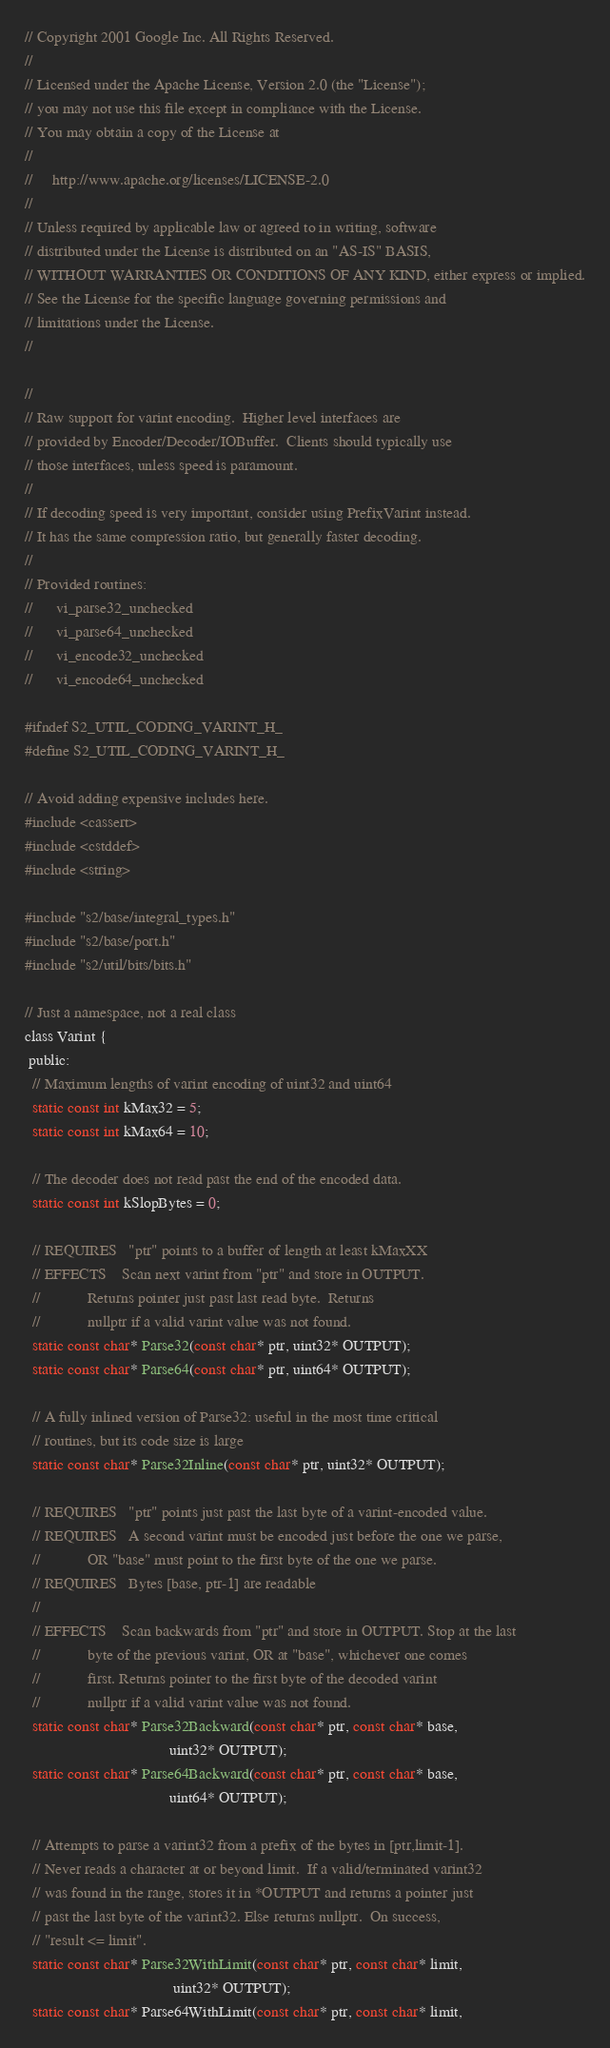<code> <loc_0><loc_0><loc_500><loc_500><_C_>// Copyright 2001 Google Inc. All Rights Reserved.
//
// Licensed under the Apache License, Version 2.0 (the "License");
// you may not use this file except in compliance with the License.
// You may obtain a copy of the License at
//
//     http://www.apache.org/licenses/LICENSE-2.0
//
// Unless required by applicable law or agreed to in writing, software
// distributed under the License is distributed on an "AS-IS" BASIS,
// WITHOUT WARRANTIES OR CONDITIONS OF ANY KIND, either express or implied.
// See the License for the specific language governing permissions and
// limitations under the License.
//

//
// Raw support for varint encoding.  Higher level interfaces are
// provided by Encoder/Decoder/IOBuffer.  Clients should typically use
// those interfaces, unless speed is paramount.
//
// If decoding speed is very important, consider using PrefixVarint instead.
// It has the same compression ratio, but generally faster decoding.
//
// Provided routines:
//      vi_parse32_unchecked
//      vi_parse64_unchecked
//      vi_encode32_unchecked
//      vi_encode64_unchecked

#ifndef S2_UTIL_CODING_VARINT_H_
#define S2_UTIL_CODING_VARINT_H_

// Avoid adding expensive includes here.
#include <cassert>
#include <cstddef>
#include <string>

#include "s2/base/integral_types.h"
#include "s2/base/port.h"
#include "s2/util/bits/bits.h"

// Just a namespace, not a real class
class Varint {
 public:
  // Maximum lengths of varint encoding of uint32 and uint64
  static const int kMax32 = 5;
  static const int kMax64 = 10;

  // The decoder does not read past the end of the encoded data.
  static const int kSlopBytes = 0;

  // REQUIRES   "ptr" points to a buffer of length at least kMaxXX
  // EFFECTS    Scan next varint from "ptr" and store in OUTPUT.
  //            Returns pointer just past last read byte.  Returns
  //            nullptr if a valid varint value was not found.
  static const char* Parse32(const char* ptr, uint32* OUTPUT);
  static const char* Parse64(const char* ptr, uint64* OUTPUT);

  // A fully inlined version of Parse32: useful in the most time critical
  // routines, but its code size is large
  static const char* Parse32Inline(const char* ptr, uint32* OUTPUT);

  // REQUIRES   "ptr" points just past the last byte of a varint-encoded value.
  // REQUIRES   A second varint must be encoded just before the one we parse,
  //            OR "base" must point to the first byte of the one we parse.
  // REQUIRES   Bytes [base, ptr-1] are readable
  //
  // EFFECTS    Scan backwards from "ptr" and store in OUTPUT. Stop at the last
  //            byte of the previous varint, OR at "base", whichever one comes
  //            first. Returns pointer to the first byte of the decoded varint
  //            nullptr if a valid varint value was not found.
  static const char* Parse32Backward(const char* ptr, const char* base,
                                     uint32* OUTPUT);
  static const char* Parse64Backward(const char* ptr, const char* base,
                                     uint64* OUTPUT);

  // Attempts to parse a varint32 from a prefix of the bytes in [ptr,limit-1].
  // Never reads a character at or beyond limit.  If a valid/terminated varint32
  // was found in the range, stores it in *OUTPUT and returns a pointer just
  // past the last byte of the varint32. Else returns nullptr.  On success,
  // "result <= limit".
  static const char* Parse32WithLimit(const char* ptr, const char* limit,
                                      uint32* OUTPUT);
  static const char* Parse64WithLimit(const char* ptr, const char* limit,</code> 